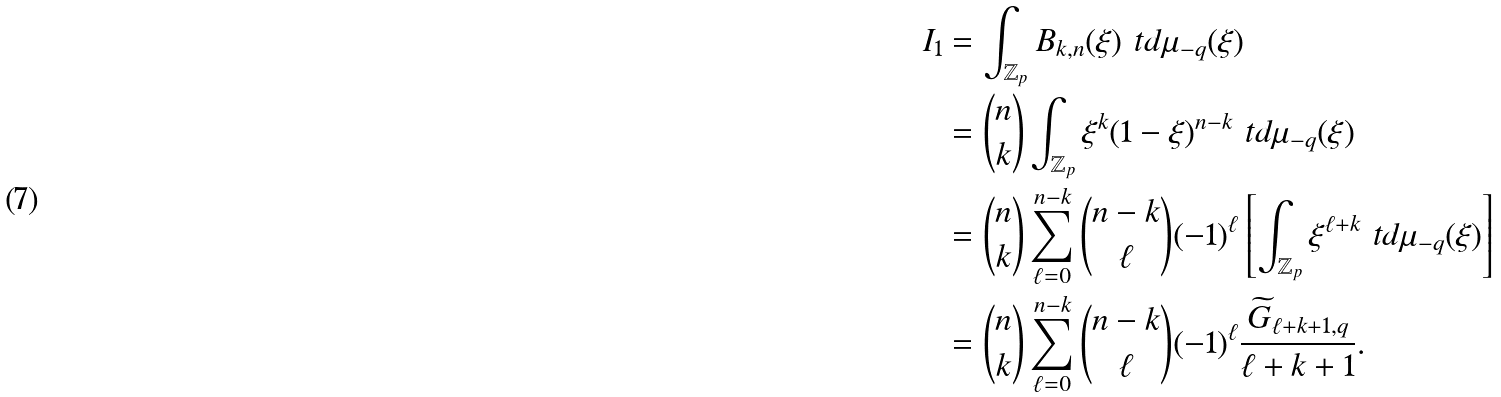<formula> <loc_0><loc_0><loc_500><loc_500>I _ { 1 } & = \int _ { \mathbb { Z } _ { p } } B _ { k , n } ( \xi ) \ t d \mu _ { - q } ( \xi ) \\ & = \binom { n } { k } \int _ { \mathbb { Z } _ { p } } \xi ^ { k } ( 1 - \xi ) ^ { n - k } \ t d \mu _ { - q } ( \xi ) \\ & = \binom { n } { k } \sum _ { \ell = 0 } ^ { n - k } \binom { n - k } { \ell } ( - 1 ) ^ { \ell } \left [ \int _ { \mathbb { Z } _ { p } } \xi ^ { \ell + k } \ t d \mu _ { - q } ( \xi ) \right ] \\ & = \binom { n } { k } \sum _ { \ell = 0 } ^ { n - k } \binom { n - k } { \ell } ( - 1 ) ^ { \ell } \frac { \widetilde { G } _ { \ell + k + 1 , q } } { \ell + k + 1 } .</formula> 